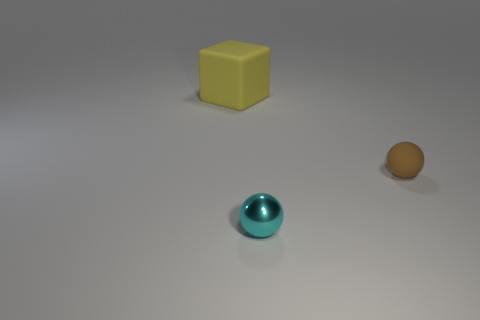What is the color of the rubber thing behind the rubber thing right of the yellow thing?
Your answer should be compact. Yellow. How many big green matte balls are there?
Offer a terse response. 0. What number of metallic objects are either red cubes or cyan spheres?
Ensure brevity in your answer.  1. What number of other objects are the same color as the metal object?
Your response must be concise. 0. There is a tiny ball that is right of the thing in front of the brown matte object; what is its material?
Your answer should be very brief. Rubber. The brown thing is what size?
Ensure brevity in your answer.  Small. What number of other cubes have the same size as the block?
Give a very brief answer. 0. What number of other tiny objects are the same shape as the brown object?
Keep it short and to the point. 1. Are there an equal number of small cyan shiny things to the left of the big matte object and tiny brown shiny balls?
Provide a succinct answer. Yes. Is there anything else that has the same size as the yellow rubber cube?
Give a very brief answer. No. 